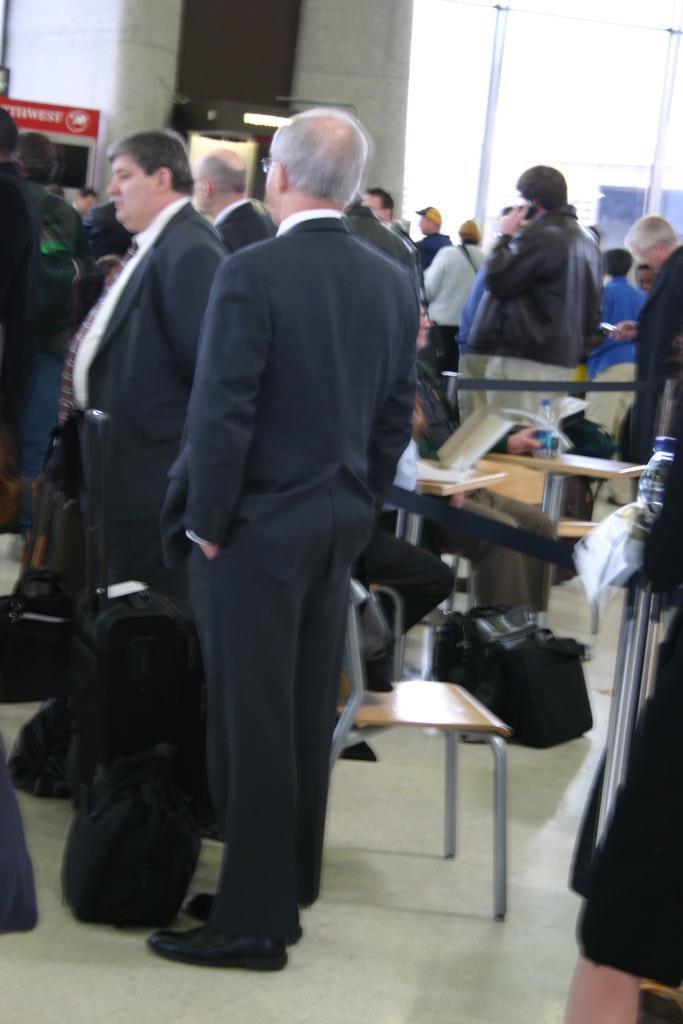Can you describe this image briefly? In this image it seems like it is a hall in which there are so many people standing on the floor. In the middle there is a person who is wearing the suit is standing on the floor. Beside him there is a bag. There are chairs and benches on the floor. 